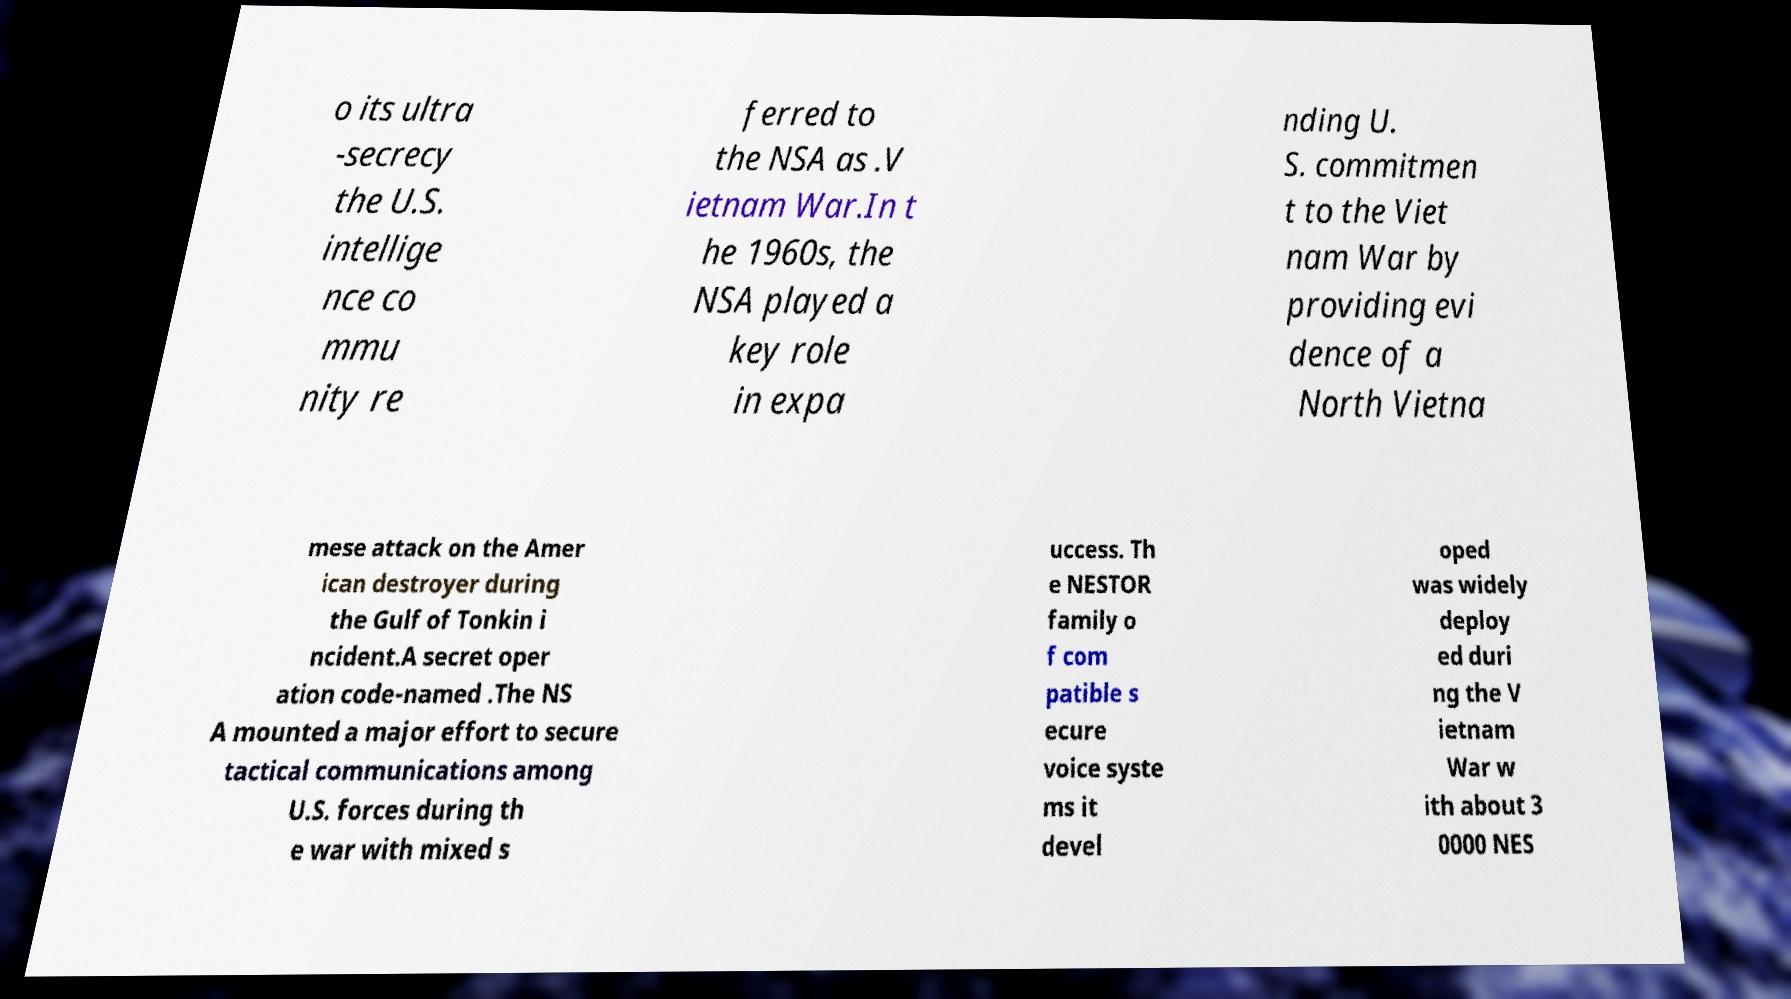For documentation purposes, I need the text within this image transcribed. Could you provide that? o its ultra -secrecy the U.S. intellige nce co mmu nity re ferred to the NSA as .V ietnam War.In t he 1960s, the NSA played a key role in expa nding U. S. commitmen t to the Viet nam War by providing evi dence of a North Vietna mese attack on the Amer ican destroyer during the Gulf of Tonkin i ncident.A secret oper ation code-named .The NS A mounted a major effort to secure tactical communications among U.S. forces during th e war with mixed s uccess. Th e NESTOR family o f com patible s ecure voice syste ms it devel oped was widely deploy ed duri ng the V ietnam War w ith about 3 0000 NES 